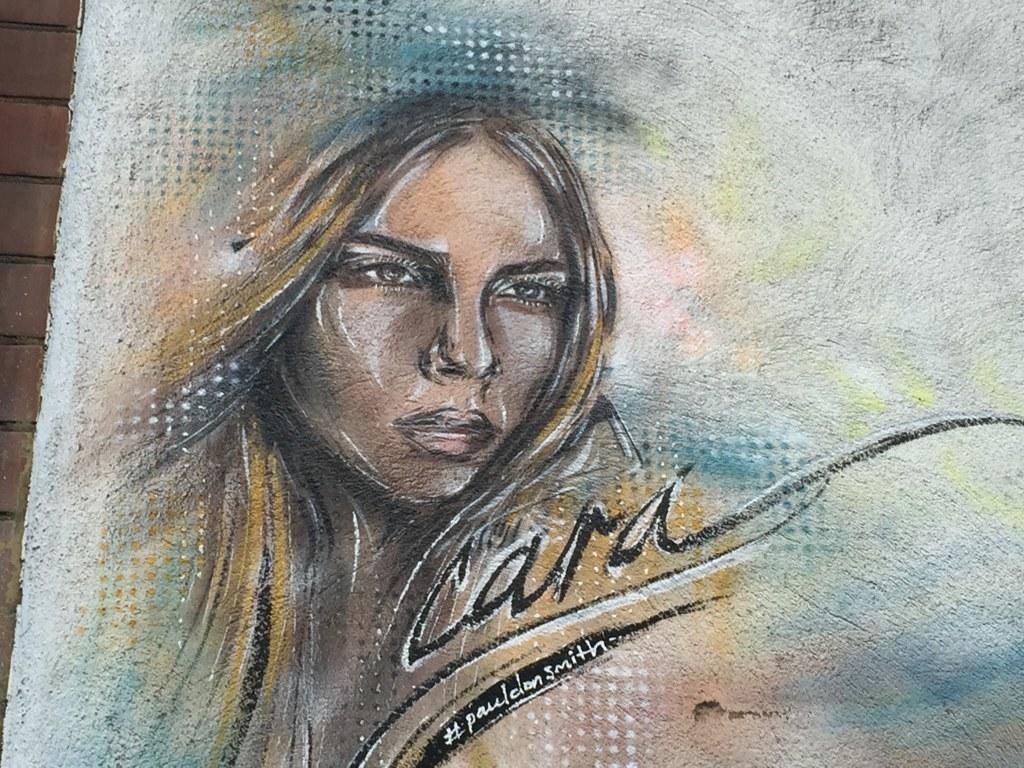Describe this image in one or two sentences. In this image there is a painting of a woman with some text on it, behind the painting there is a wall. 